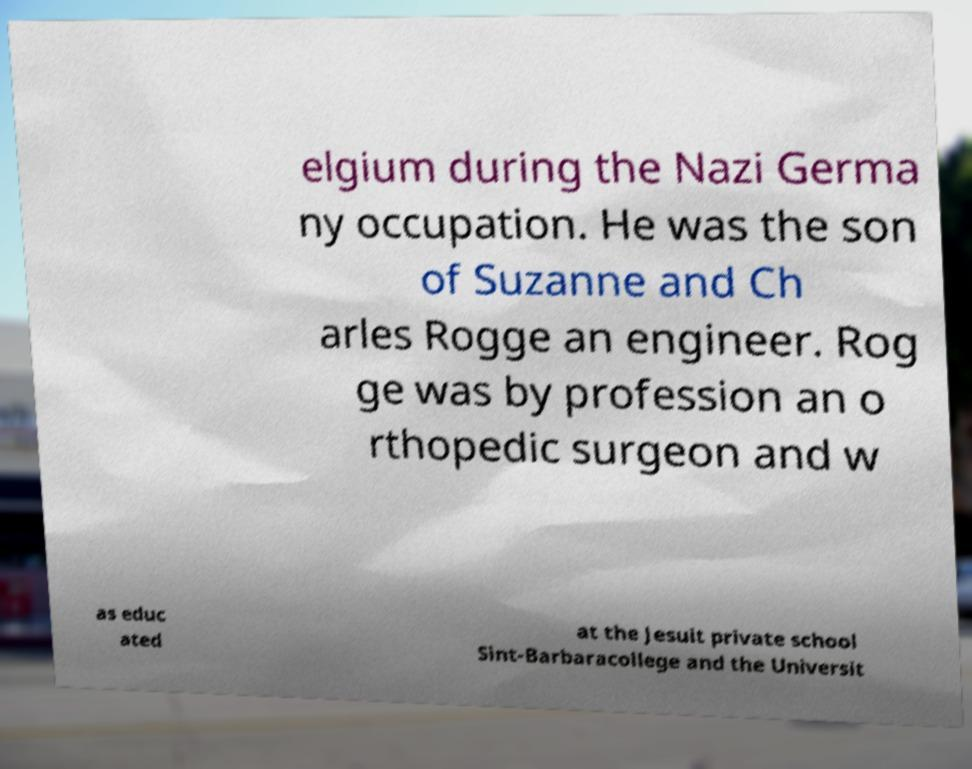What messages or text are displayed in this image? I need them in a readable, typed format. elgium during the Nazi Germa ny occupation. He was the son of Suzanne and Ch arles Rogge an engineer. Rog ge was by profession an o rthopedic surgeon and w as educ ated at the Jesuit private school Sint-Barbaracollege and the Universit 